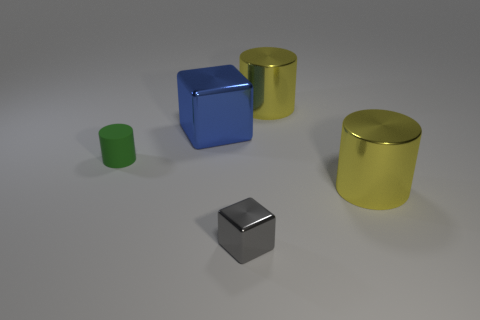What shape is the gray thing that is the same size as the green rubber object?
Offer a terse response. Cube. Is there a blue thing that has the same shape as the tiny gray metallic object?
Your answer should be compact. Yes. There is a thing that is on the left side of the blue thing; is it the same size as the small metal thing?
Offer a terse response. Yes. There is a shiny thing that is in front of the blue block and right of the gray thing; what is its size?
Provide a short and direct response. Large. How many other things are the same material as the small cylinder?
Provide a short and direct response. 0. What is the size of the cylinder that is behind the matte object?
Keep it short and to the point. Large. What number of big things are brown metallic cylinders or yellow shiny things?
Your answer should be compact. 2. There is a blue cube; are there any tiny gray shiny things on the left side of it?
Your answer should be very brief. No. What is the size of the rubber thing that is to the left of the large metallic thing that is left of the small gray metal thing?
Your response must be concise. Small. Are there an equal number of large blue objects on the left side of the tiny metal cube and blocks that are in front of the tiny cylinder?
Your response must be concise. Yes. 